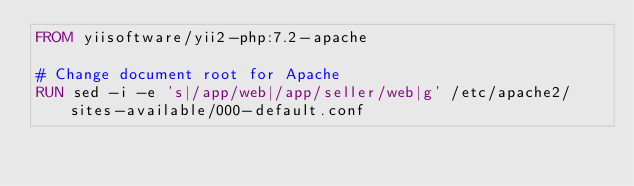<code> <loc_0><loc_0><loc_500><loc_500><_Dockerfile_>FROM yiisoftware/yii2-php:7.2-apache

# Change document root for Apache
RUN sed -i -e 's|/app/web|/app/seller/web|g' /etc/apache2/sites-available/000-default.conf</code> 